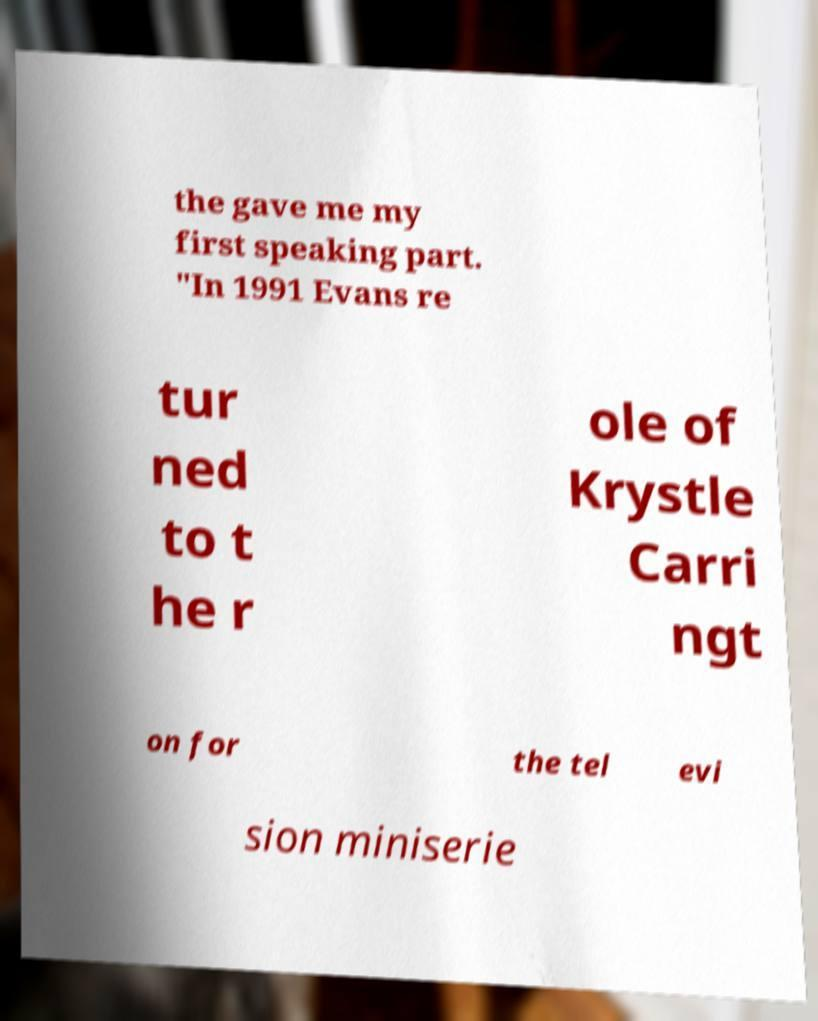What messages or text are displayed in this image? I need them in a readable, typed format. the gave me my first speaking part. "In 1991 Evans re tur ned to t he r ole of Krystle Carri ngt on for the tel evi sion miniserie 